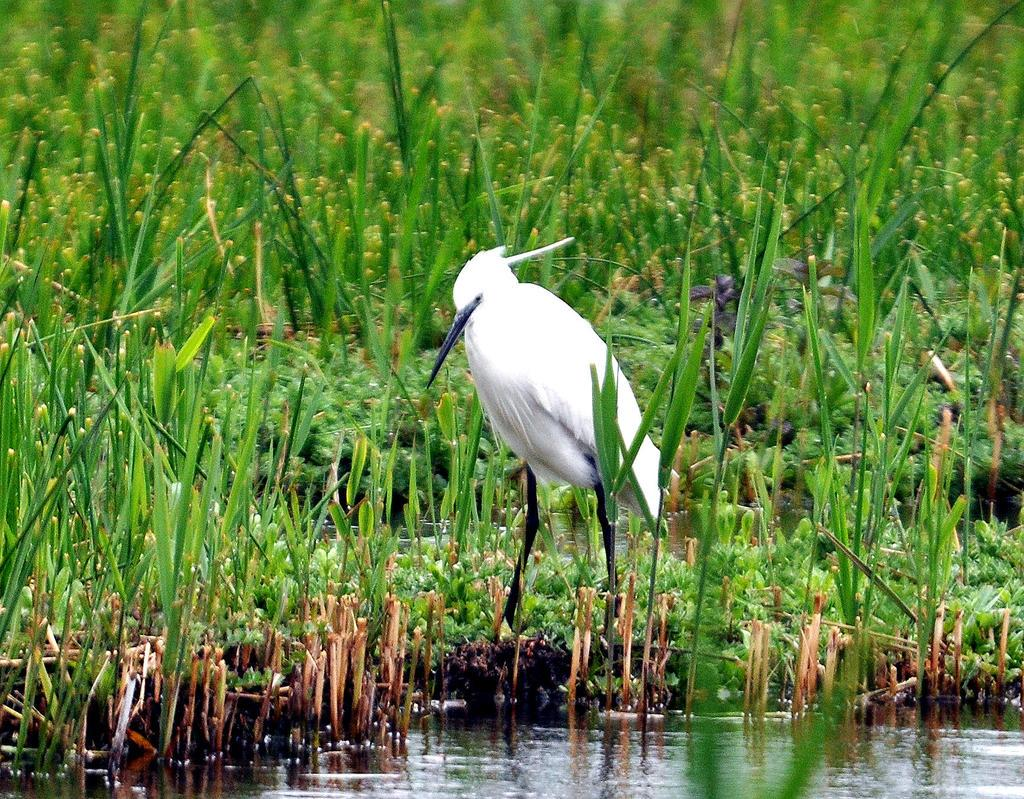What is the main subject in the center of the image? There is a bird in the center of the image. What type of vegetation can be seen in the image? There is grass in the image. What is located at the bottom of the image? There is water at the bottom of the image. What type of fang can be seen in the image? There are no fangs present in the image; it features a bird, grass, and water. Can you recite a verse from the image? There is no text or verse present in the image; it is a visual representation of a bird, grass, and water. 